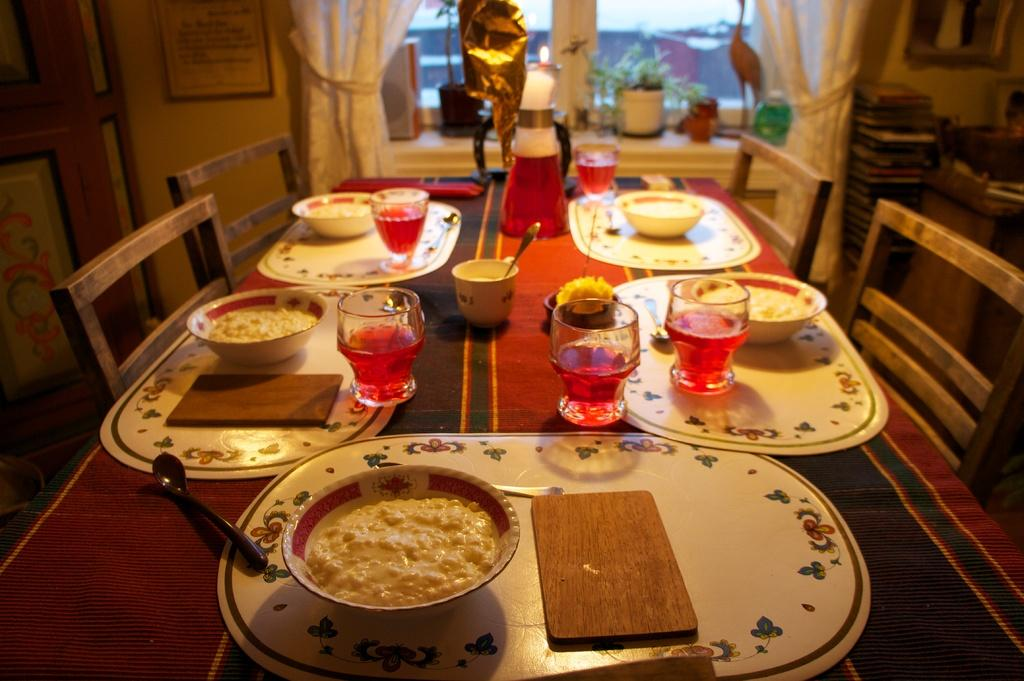What type of containers are holding food in the image? There are bowls holding food in the image. What other types of containers are visible in the image? There are glasses and cups in the image. Where are these containers located? The items are on a table. What might be used for sitting around the table? There are chairs around the table. What is the mass of the swing in the image? There is no swing present in the image. 